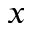<formula> <loc_0><loc_0><loc_500><loc_500>x</formula> 